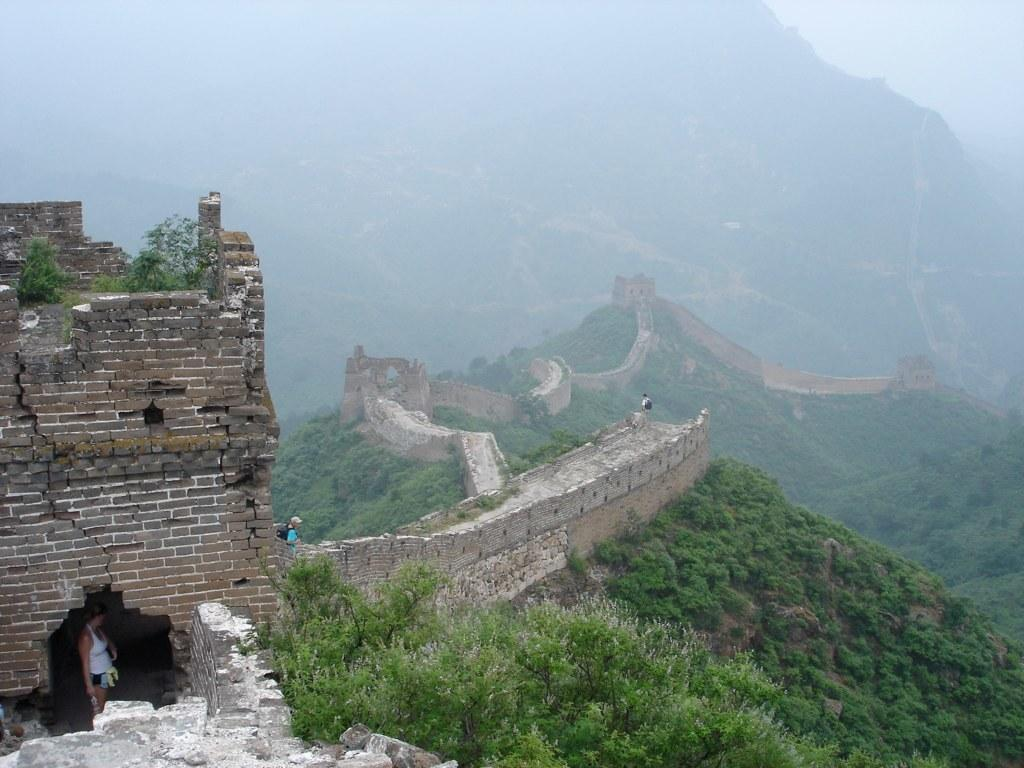What famous landmark is visible in the image? The Great Wall of China is visible in the image. What can be seen near the Great Wall of China? There are people standing near the Great Wall of China. What type of vegetation is visible in the background of the image? There are trees and plants on the mountain in the background of the image. What is visible in the sky in the image? The sky is visible in the background of the image. How many horses are visible on the Great Wall of China in the image? There are no horses visible on the Great Wall of China in the image. What type of nose does the son have in the image? There is no son present in the image, so it is not possible to determine the type of nose he might have. 